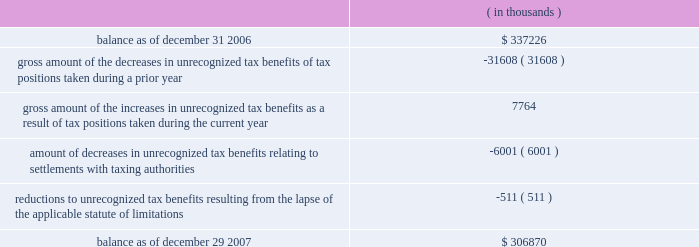The changes in the gross amount of unrecognized tax benefits for the year ended december 29 , 2007 are as follows: .
As of december 29 , 2007 , $ 228.4 million of unrecognized tax benefits would , if recognized , reduce the effective tax rate , as compared to $ 232.1 million as of december 31 , 2006 , the first day of cadence 2019s fiscal year .
The total amounts of interest and penalties recognized in the consolidated income statement for the year ended december 29 , 2007 resulted in net tax benefits of $ 11.1 million and $ 0.4 million , respectively , primarily due to the effective settlement of tax audits during the year .
The total amounts of gross accrued interest and penalties recognized in the consolidated balance sheets as of december 29 , 2007 , were $ 47.9 million and $ 9.7 million , respectively as compared to $ 65.8 million and $ 10.1 million , respectively as of december 31 , 2006 .
Note 9 .
Acquisitions for each of the acquisitions described below , the results of operations and the estimated fair value of the assets acquired and liabilities assumed have been included in cadence 2019s consolidated financial statements from the date of the acquisition .
Comparative pro forma financial information for all 2007 , 2006 and 2005 acquisitions have not been presented because the results of operations were not material to cadence 2019s consolidated financial statements .
2007 acquisitions during 2007 , cadence acquired invarium , inc. , a san jose-based developer of advanced lithography-modeling and pattern-synthesis technology , and clear shape technologies , inc. , a san jose-based design for manufacturing technology company specializing in design-side solutions to minimize yield loss for advanced semiconductor integrated circuits .
Cadence acquired these two companies for an aggregate purchase price of $ 75.5 million , which included the payment of cash , the fair value of assumed options and acquisition costs .
The $ 45.7 million of goodwill recorded in connection with these acquisitions is not expected to be deductible for income tax purposes .
Prior to acquiring clear shape technologies , inc. , cadence had an investment of $ 2.0 million in the company , representing a 12% ( 12 % ) ownership interest , which had been accounted for under the cost method of accounting .
In accordance with sfas no .
141 , 201cbusiness combinations , 201d cadence accounted for this acquisition as a step acquisition .
Subsequent adjustments to the purchase price of these acquired companies are included in the 201cother 201d line of the changes of goodwill table in note 10 below .
2006 acquisition in march 2006 , cadence acquired a company for an aggregate initial purchase price of $ 25.8 million , which included the payment of cash , the fair value of assumed options and acquisition costs .
The preliminary allocation of the purchase price was recorded as $ 17.4 million of goodwill , $ 9.4 million of identifiable intangible assets and $ ( 1.0 ) million of net liabilities .
The $ 17.4 million of goodwill recorded in connection with this acquisition is not expected to be deductible for income tax purposes .
Subsequent adjustments to the purchase price of this acquired company are included in the 201cother 201d line of the changes of goodwill table in note 10 below. .
What is the percentage change in the gross accrued interest from 2006 to 2007? 
Computations: ((47.9 - 65.8) / 65.8)
Answer: -0.27204. 